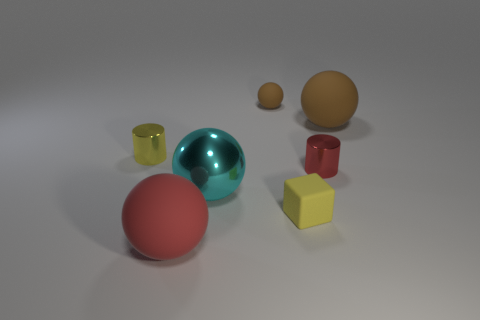Is there anything else that is the same size as the red rubber thing?
Provide a short and direct response. Yes. Are the yellow block and the cylinder in front of the yellow metal object made of the same material?
Your answer should be very brief. No. What material is the tiny thing that is on the right side of the large red rubber sphere and behind the small red shiny cylinder?
Offer a terse response. Rubber. There is a big matte object behind the tiny metal cylinder that is on the left side of the large cyan ball; what is its color?
Keep it short and to the point. Brown. What material is the cylinder on the right side of the yellow rubber thing?
Provide a succinct answer. Metal. Are there fewer gray metal balls than red cylinders?
Offer a very short reply. Yes. Is the shape of the cyan thing the same as the tiny object that is to the left of the red matte sphere?
Your answer should be compact. No. The large thing that is on the left side of the small yellow matte thing and to the right of the big red rubber sphere has what shape?
Provide a succinct answer. Sphere. Is the number of tiny red metallic cylinders on the left side of the tiny yellow block the same as the number of spheres in front of the large red rubber thing?
Make the answer very short. Yes. There is a small thing that is behind the big brown object; is its shape the same as the large brown matte thing?
Offer a very short reply. Yes. 